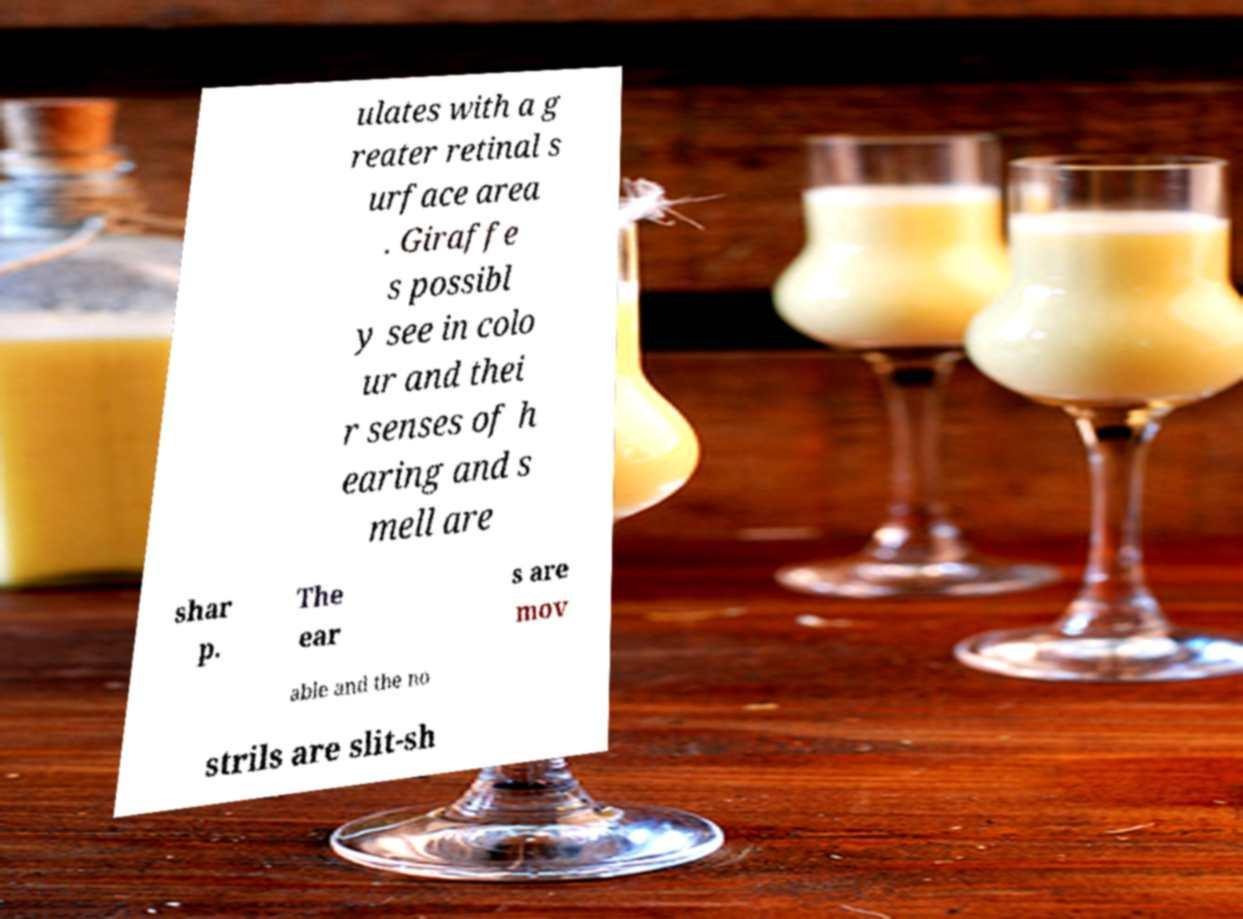I need the written content from this picture converted into text. Can you do that? ulates with a g reater retinal s urface area . Giraffe s possibl y see in colo ur and thei r senses of h earing and s mell are shar p. The ear s are mov able and the no strils are slit-sh 